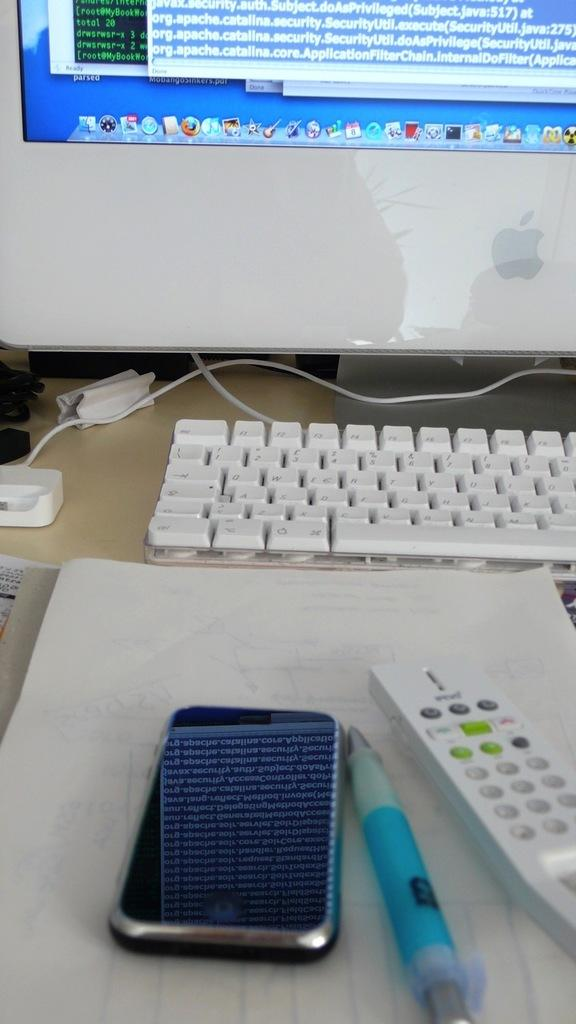<image>
Present a compact description of the photo's key features. A smartphone and a pen lay in front of a Apple computer that says org.apache.catalina on the screen. 